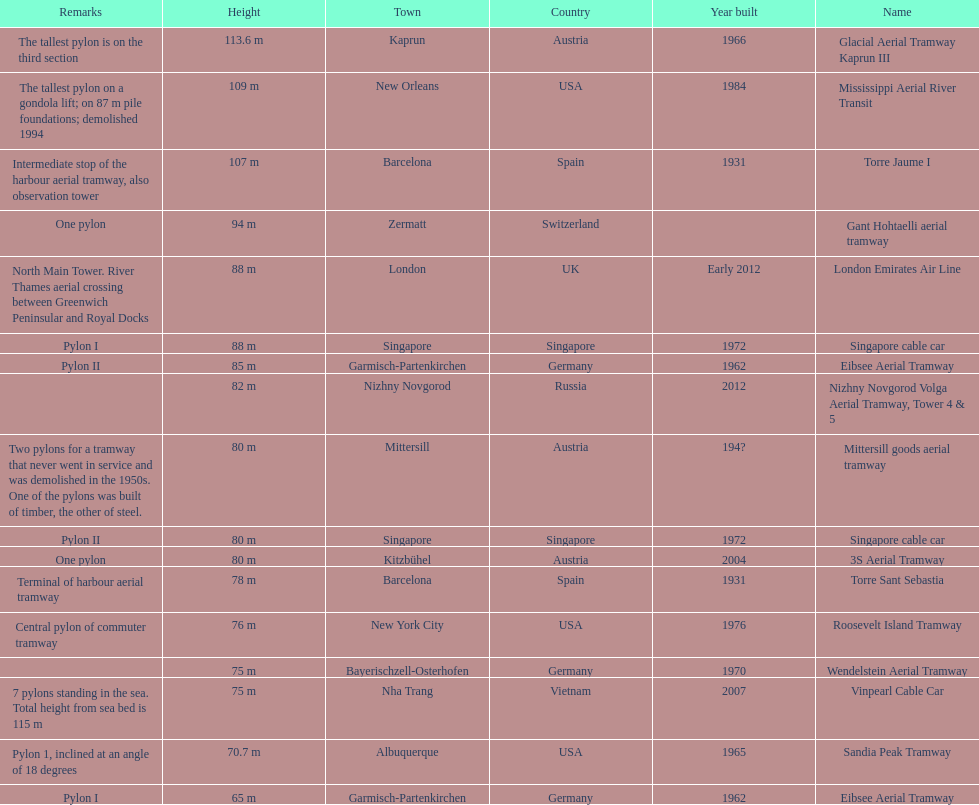What is the total number of tallest pylons in austria? 3. 